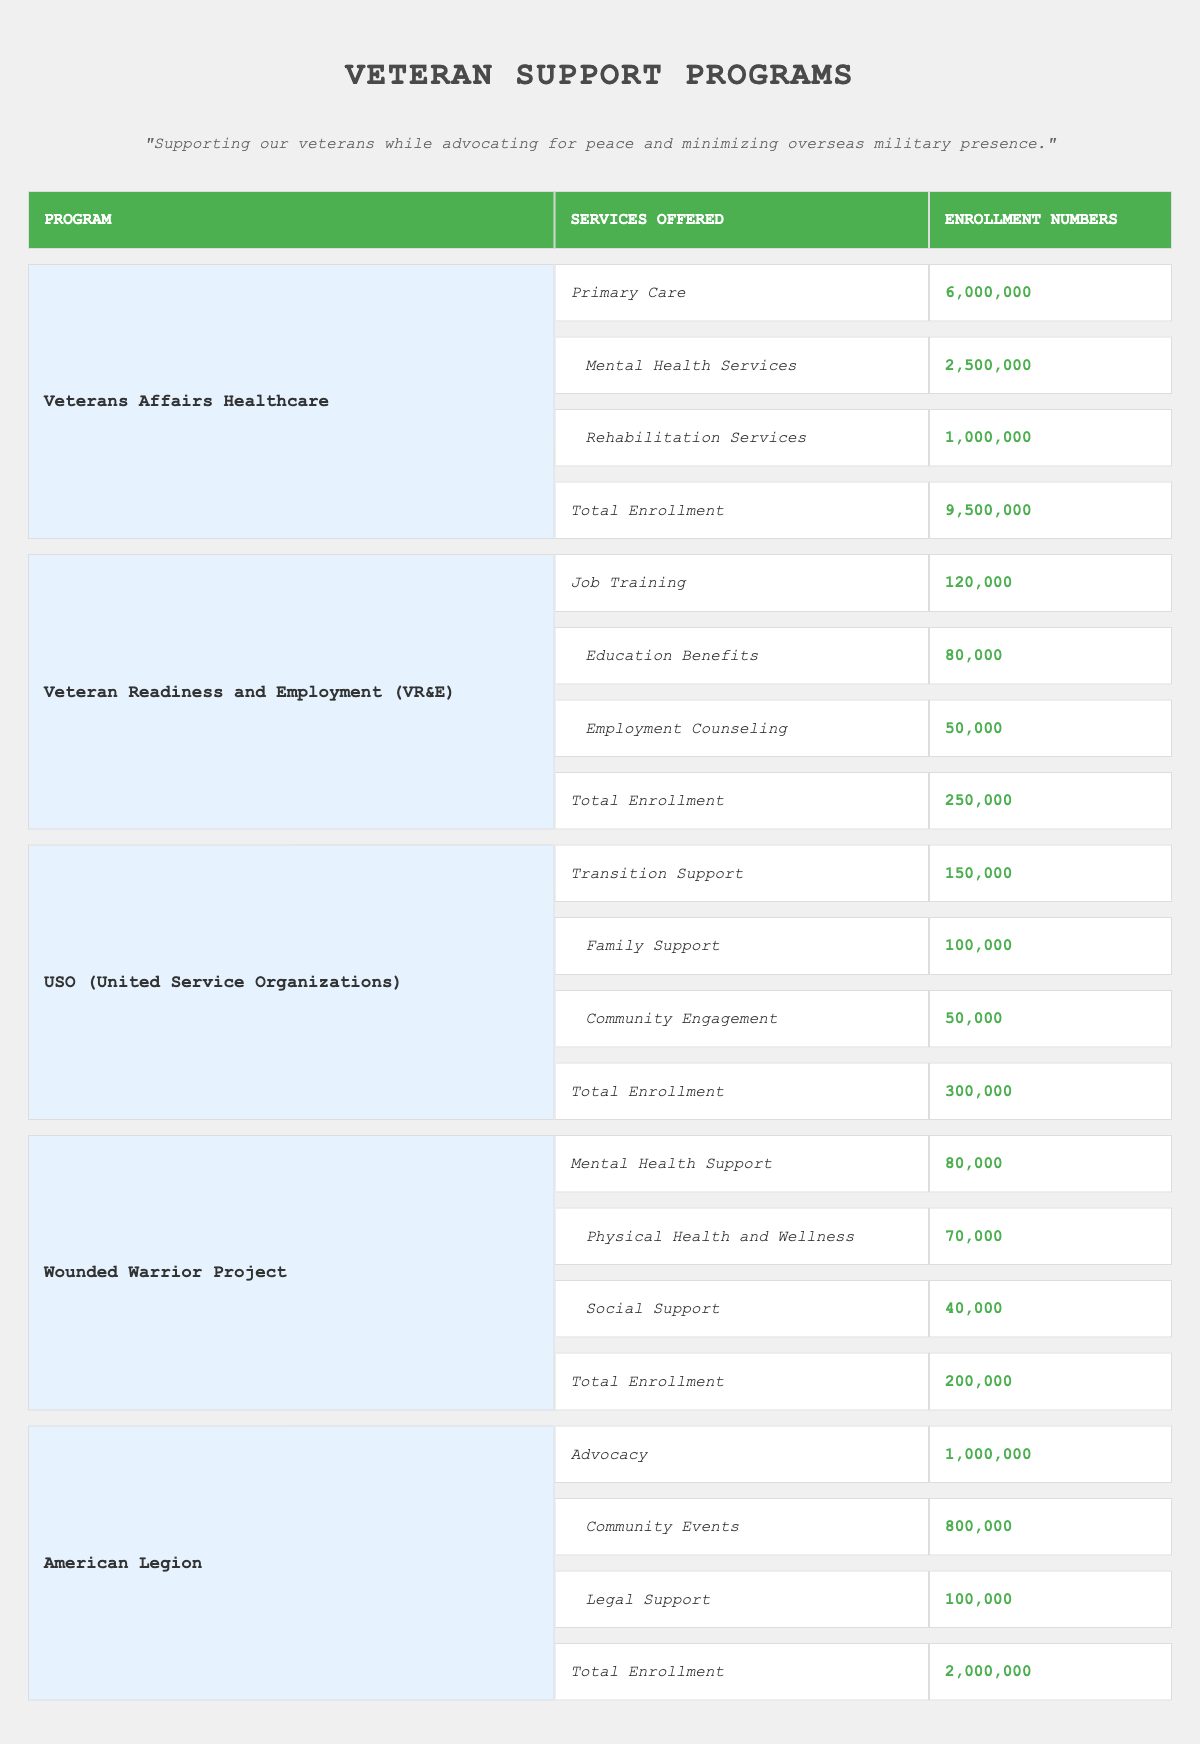What is the total enrollment for Veterans Affairs Healthcare? The total enrollment for Veterans Affairs Healthcare is clearly noted in the table as 9,500,000.
Answer: 9,500,000 How many veterans are enrolled in Mental Health Services under the Veterans Affairs Healthcare program? The enrollment number for Mental Health Services is specified in the table as 2,500,000.
Answer: 2,500,000 Which program has the lowest total enrollment? The total enrollment figures indicate that the Veteran Readiness and Employment (VR&E) program has the lowest total enrollment at 250,000.
Answer: Veteran Readiness and Employment (VR&E) What is the combined enrollment for all services offered by the Wounded Warrior Project? Adding the enrollment numbers for the Wounded Warrior Project services gives: 80,000 (Mental Health Support) + 70,000 (Physical Health and Wellness) + 40,000 (Social Support) = 190,000.
Answer: 190,000 Is the total enrollment for the American Legion greater than that of the USO? The American Legion has a total enrollment of 2,000,000, while the USO has a total enrollment of 300,000. Therefore, the American Legion’s total enrollment is indeed greater than that of the USO.
Answer: Yes What is the difference in enrollment between Primary Care and Employment Counseling? The enrollment for Primary Care is 6,000,000 and for Employment Counseling, it is 50,000. The difference is 6,000,000 - 50,000 = 5,950,000.
Answer: 5,950,000 How many veterans utilize Transition Support and Family Support combined in the USO program? The combined enrollment for Transition Support (150,000) and Family Support (100,000) in the USO program is 150,000 + 100,000 = 250,000.
Answer: 250,000 Which program offers the most diverse range of services based on the number of different services? The Veterans Affairs Healthcare program offers three distinct services (Primary Care, Mental Health Services, Rehabilitation Services), while others like Wounded Warrior Project also offer three. However, programs like the American Legion and VR&E offer fewer services. Thus, it can be stated that multiple programs share a similar breadth.
Answer: Multiple programs offer the same diversity Who has more total enrollment: the Wounded Warrior Project or the USO? The Wounded Warrior Project has a total enrollment of 200,000, while the USO has 300,000. Therefore, more veterans are enrolled in the USO than in the Wounded Warrior Project.
Answer: USO 